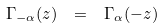Convert formula to latex. <formula><loc_0><loc_0><loc_500><loc_500>\Gamma _ { - \alpha } ( z ) \, \ = \, \ \Gamma _ { \alpha } ( - z )</formula> 